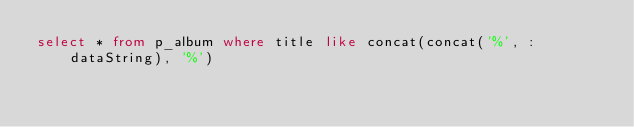<code> <loc_0><loc_0><loc_500><loc_500><_SQL_>select * from p_album where title like concat(concat('%', :dataString), '%')</code> 